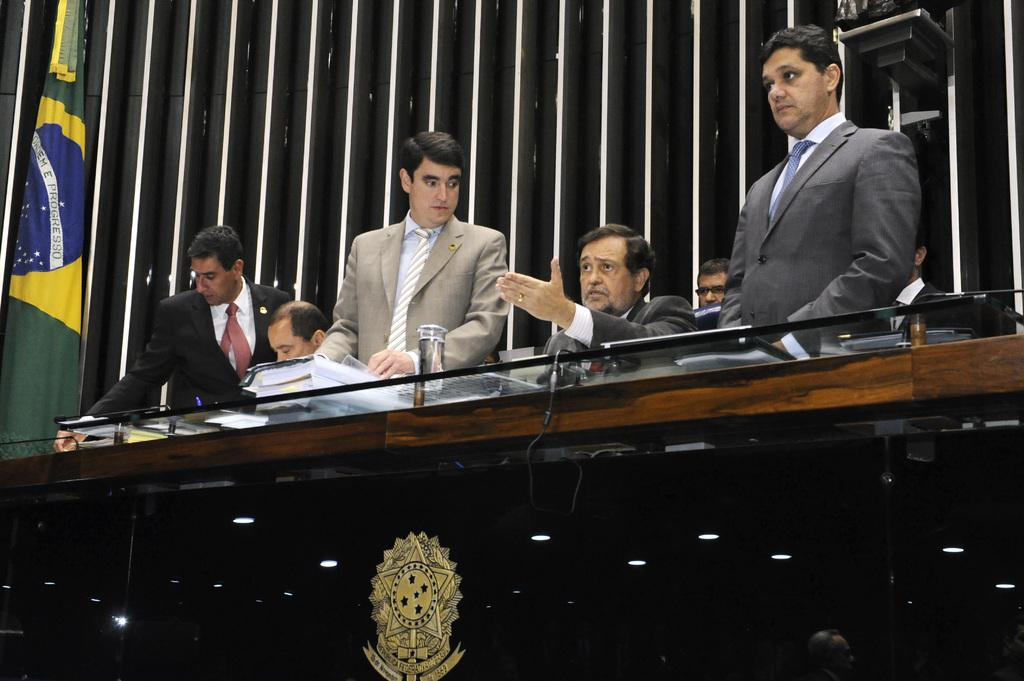What are the people in the image doing? The people in the image are sitting on the stage. What else can be seen on the stage besides the people? There is a table on the stage. What is the background of the image like? There is a wooden panel wall in the background, and there are flags present. What is on the table on the stage? There is a golden logo on the table. Can you see a ghost interacting with the people on the stage in the image? No, there is no ghost present in the image. What type of harmony is being played by the people on the stage? The image does not provide any information about music or harmony being played by the people on the stage. 